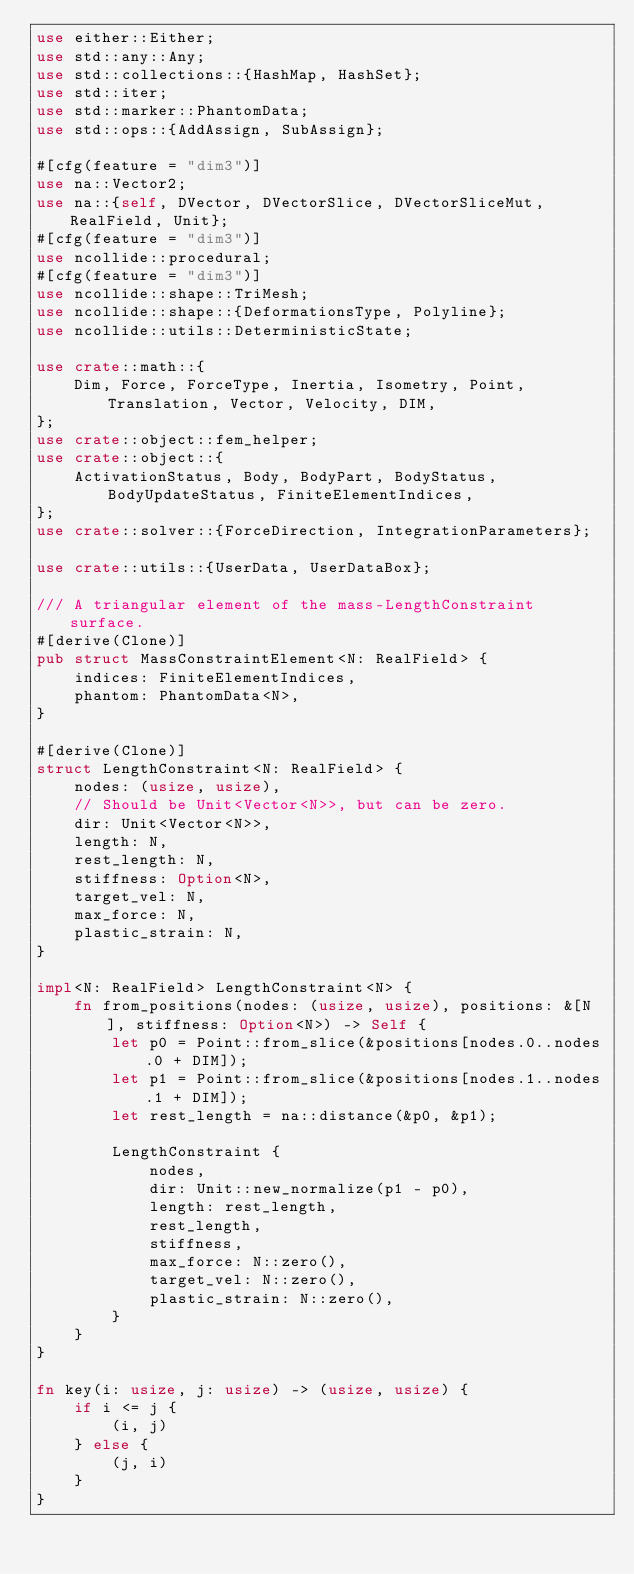Convert code to text. <code><loc_0><loc_0><loc_500><loc_500><_Rust_>use either::Either;
use std::any::Any;
use std::collections::{HashMap, HashSet};
use std::iter;
use std::marker::PhantomData;
use std::ops::{AddAssign, SubAssign};

#[cfg(feature = "dim3")]
use na::Vector2;
use na::{self, DVector, DVectorSlice, DVectorSliceMut, RealField, Unit};
#[cfg(feature = "dim3")]
use ncollide::procedural;
#[cfg(feature = "dim3")]
use ncollide::shape::TriMesh;
use ncollide::shape::{DeformationsType, Polyline};
use ncollide::utils::DeterministicState;

use crate::math::{
    Dim, Force, ForceType, Inertia, Isometry, Point, Translation, Vector, Velocity, DIM,
};
use crate::object::fem_helper;
use crate::object::{
    ActivationStatus, Body, BodyPart, BodyStatus, BodyUpdateStatus, FiniteElementIndices,
};
use crate::solver::{ForceDirection, IntegrationParameters};

use crate::utils::{UserData, UserDataBox};

/// A triangular element of the mass-LengthConstraint surface.
#[derive(Clone)]
pub struct MassConstraintElement<N: RealField> {
    indices: FiniteElementIndices,
    phantom: PhantomData<N>,
}

#[derive(Clone)]
struct LengthConstraint<N: RealField> {
    nodes: (usize, usize),
    // Should be Unit<Vector<N>>, but can be zero.
    dir: Unit<Vector<N>>,
    length: N,
    rest_length: N,
    stiffness: Option<N>,
    target_vel: N,
    max_force: N,
    plastic_strain: N,
}

impl<N: RealField> LengthConstraint<N> {
    fn from_positions(nodes: (usize, usize), positions: &[N], stiffness: Option<N>) -> Self {
        let p0 = Point::from_slice(&positions[nodes.0..nodes.0 + DIM]);
        let p1 = Point::from_slice(&positions[nodes.1..nodes.1 + DIM]);
        let rest_length = na::distance(&p0, &p1);

        LengthConstraint {
            nodes,
            dir: Unit::new_normalize(p1 - p0),
            length: rest_length,
            rest_length,
            stiffness,
            max_force: N::zero(),
            target_vel: N::zero(),
            plastic_strain: N::zero(),
        }
    }
}

fn key(i: usize, j: usize) -> (usize, usize) {
    if i <= j {
        (i, j)
    } else {
        (j, i)
    }
}
</code> 